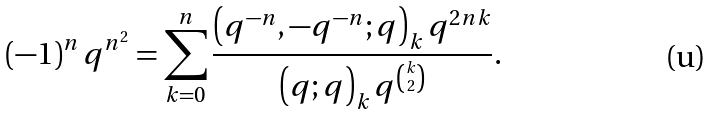Convert formula to latex. <formula><loc_0><loc_0><loc_500><loc_500>\left ( - 1 \right ) ^ { n } q ^ { n ^ { 2 } } = \sum _ { k = 0 } ^ { n } \frac { \left ( q ^ { - n } , - q ^ { - n } ; q \right ) _ { k } q ^ { 2 n k } } { \left ( q ; q \right ) _ { k } q ^ { \binom { k } { 2 } } } .</formula> 